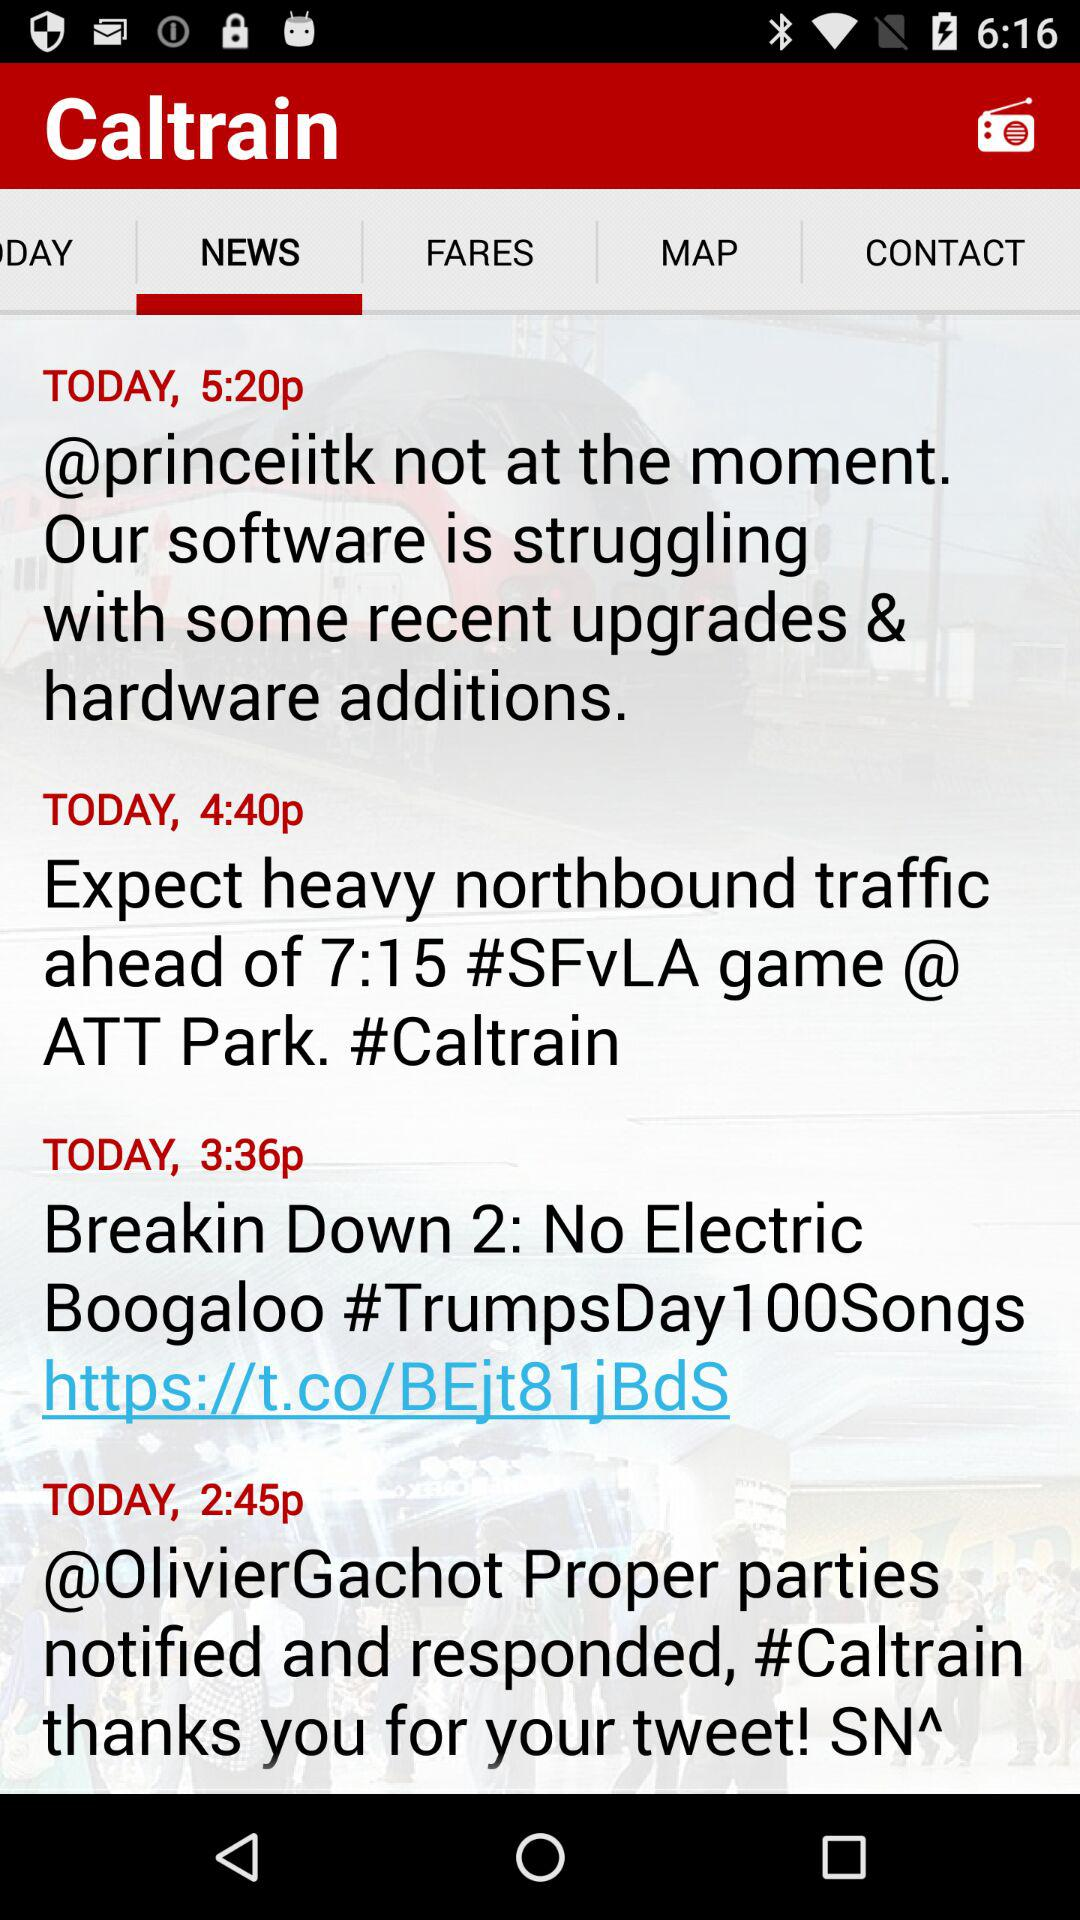At what time the news about "Expect heavy northbound traffic ahead of 7:15 #SFVLA game @ ATT Park. #Caltrain" posted? The news about "Expect heavy northbound traffic ahead of 7:15 #SFVLA game @ ATT Park. #Caltrain" was posted at "4:40p". 